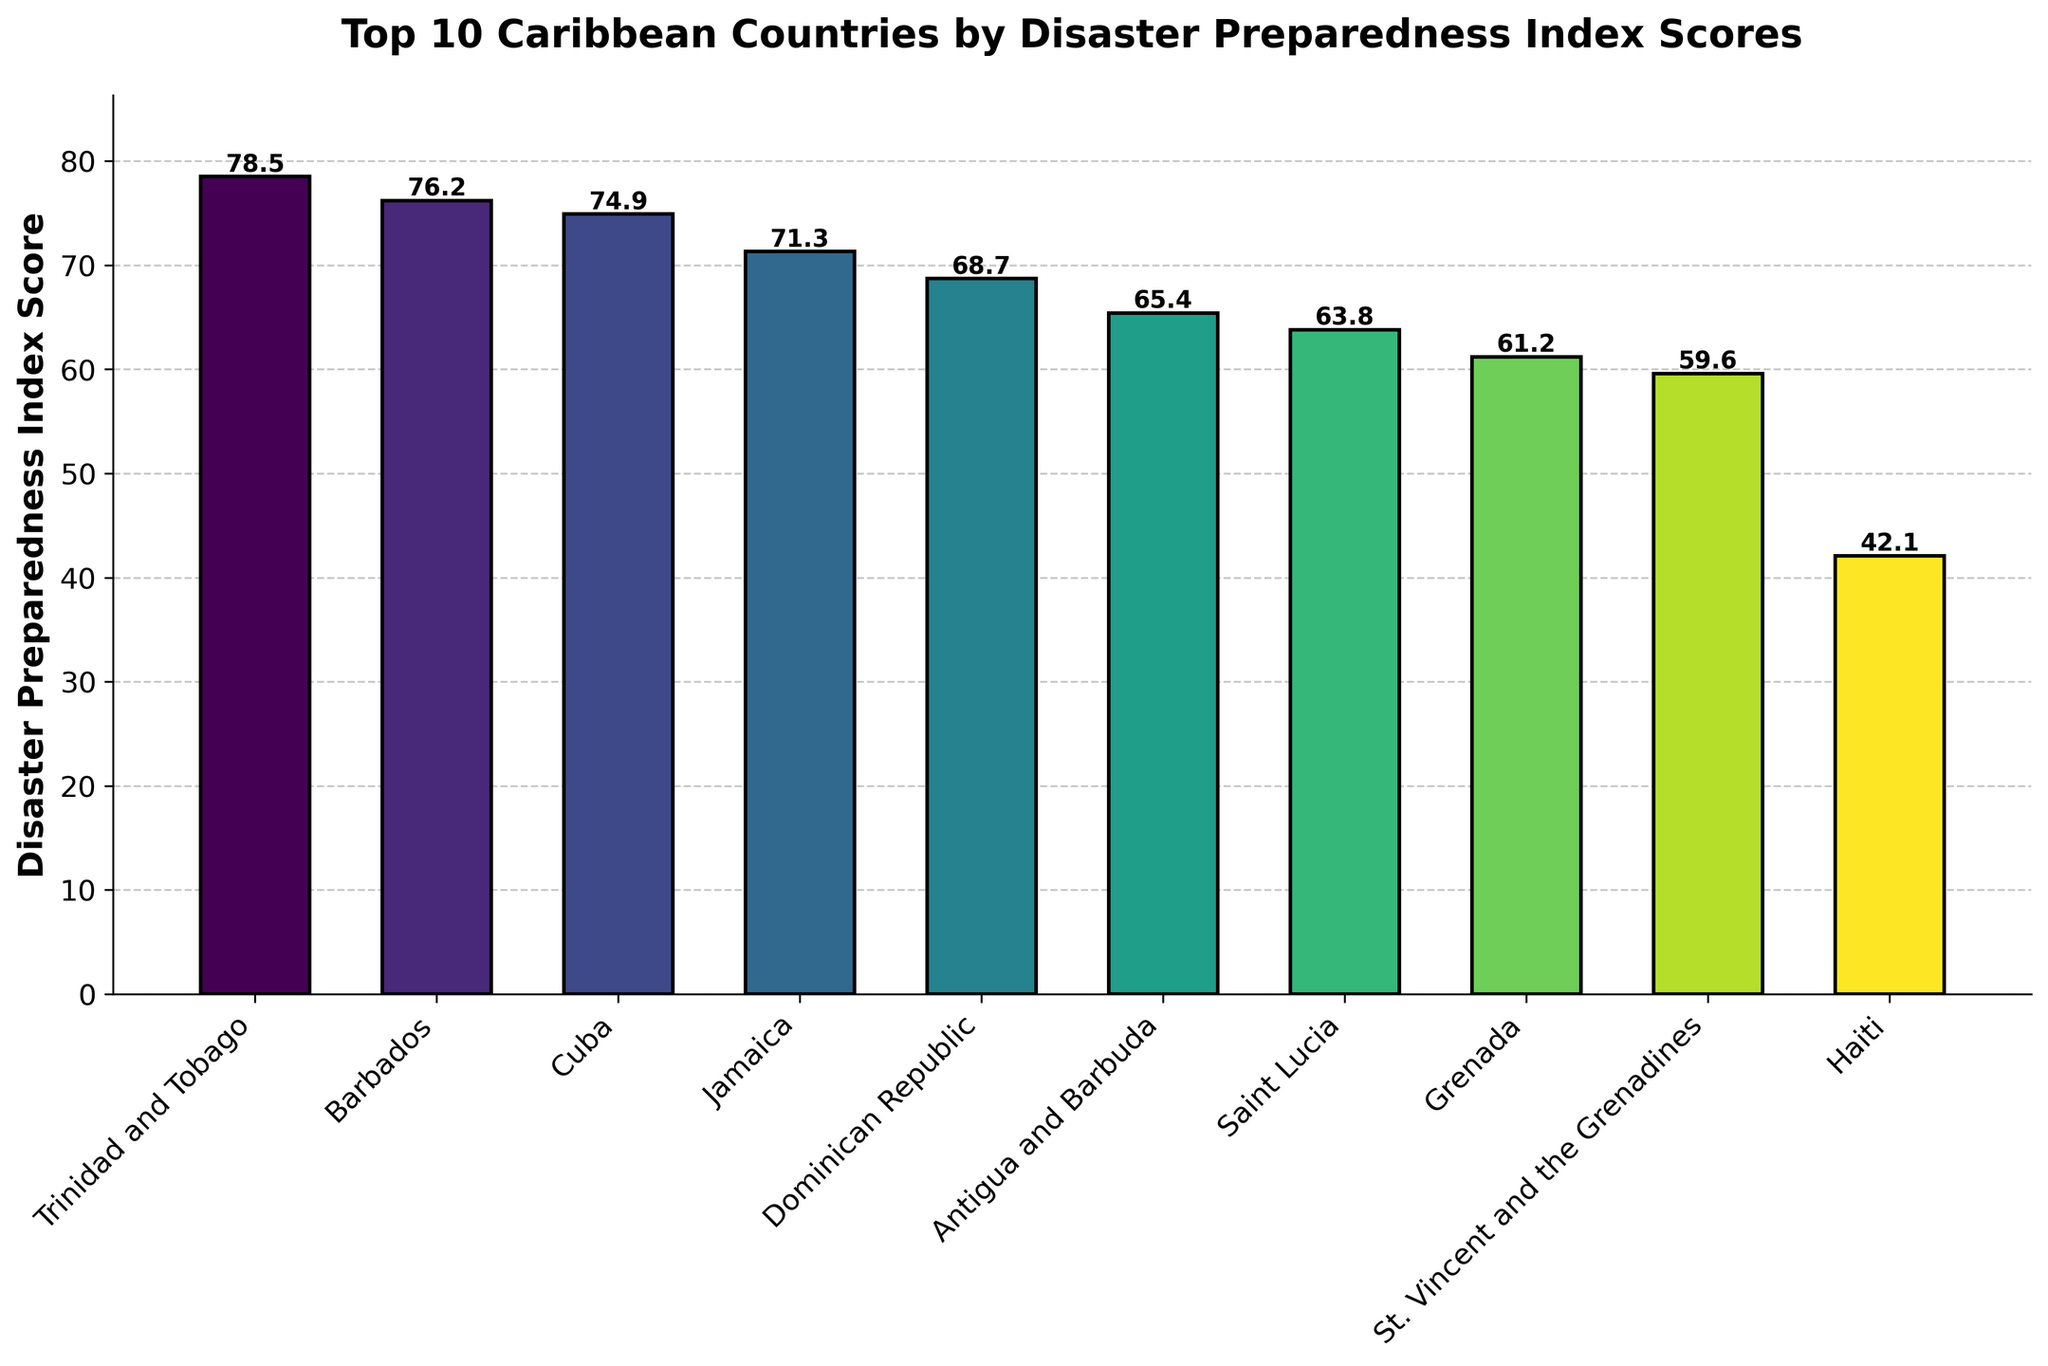Which country has the highest Disaster Preparedness Index Score? The tallest bar represents the country with the highest Disaster Preparedness Index Score. Trinidad and Tobago has the tallest bar with a score of 78.5.
Answer: Trinidad and Tobago Which country has the lowest Disaster Preparedness Index Score? The shortest bar represents the country with the lowest score. Haiti has the shortest bar with a score of 42.1.
Answer: Haiti What is the difference in Disaster Preparedness Index Score between Trinidad and Tobago and Haiti? First, identify the scores for Trinidad and Tobago (78.5) and Haiti (42.1). Subtract the score of Haiti from the score of Trinidad and Tobago: 78.5 - 42.1 = 36.4.
Answer: 36.4 How many countries have a Disaster Preparedness Index Score above 70? Count the number of bars with heights above the 70 mark. Trinidad and Tobago (78.5), Barbados (76.2), Cuba (74.9), and Jamaica (71.3)—a total of 4 countries.
Answer: 4 What is the average Disaster Preparedness Index Score for the top 3 countries? First, identify the scores for the top 3 countries: Trinidad and Tobago (78.5), Barbados (76.2), and Cuba (74.9). Add these scores: 78.5 + 76.2 + 74.9 = 229.6. Divide by the number of countries (3): 229.6 / 3 ≈ 76.53.
Answer: 76.53 Which country has a score closest to 60? Find the bar whose height is nearest to 60. Saint Lucia has a score of 63.8, which is closest to 60.
Answer: Saint Lucia How much higher is the score of Jamaica compared to Grenada? Identify the scores for Jamaica (71.3) and Grenada (61.2). Subtract the score of Grenada from Jamaica: 71.3 - 61.2 = 10.1.
Answer: 10.1 What is the sum of the Disaster Preparedness Index Scores for the Dominican Republic and Antigua and Barbuda? First, find the scores for the Dominican Republic (68.7) and Antigua and Barbuda (65.4). Add these scores together: 68.7 + 65.4 = 134.1.
Answer: 134.1 Which two countries have scores below 50? Identify the bars with heights below the 50 mark. Only Haiti has a bar below 50 with a score of 42.1.
Answer: Haiti 